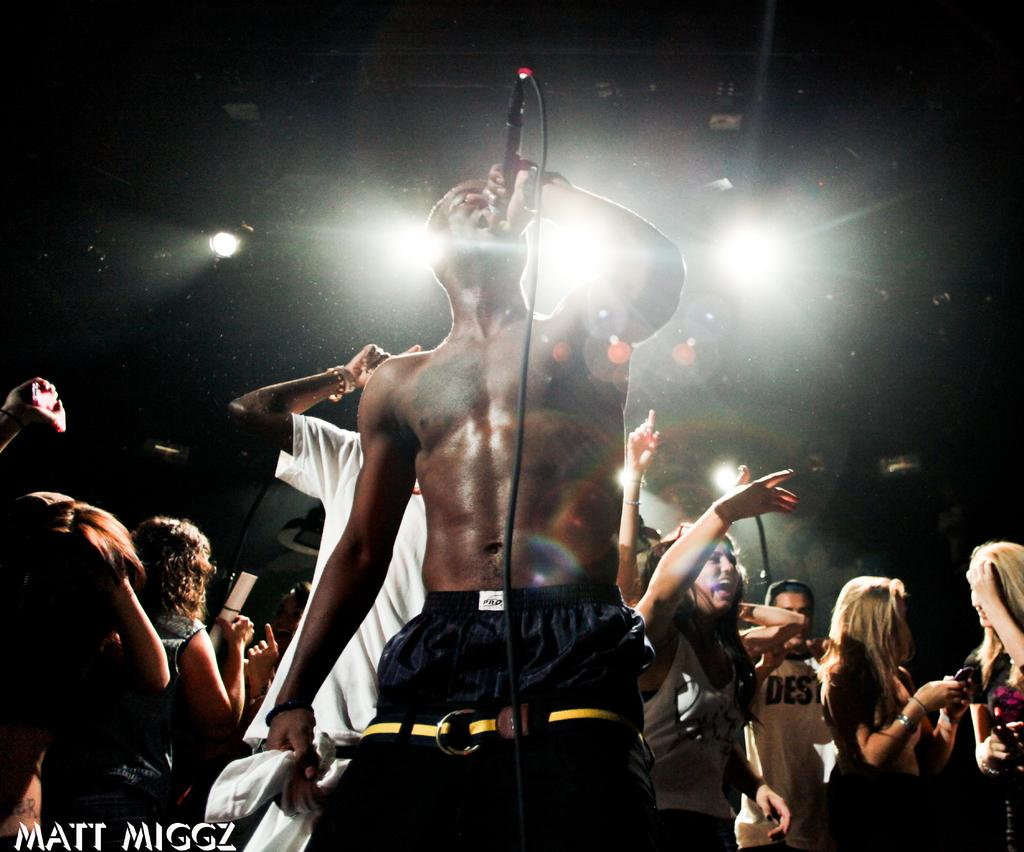How many people are in the image? There is a group of people in the image. What is the man holding in the image? The man is standing and holding a microphone. What can be seen in the background of the image? There are lights visible in the background of the image. What type of skin condition can be seen on the hen in the image? There is no hen present in the image; it features a group of people and a man holding a microphone. What type of system is being used to control the lights in the image? There is no information provided about the system used to control the lights in the image. 